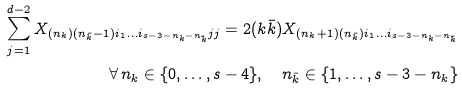<formula> <loc_0><loc_0><loc_500><loc_500>\sum _ { j = 1 } ^ { d - 2 } X _ { ( n _ { k } ) ( n _ { \bar { k } } - 1 ) i _ { 1 } \dots i _ { s - 3 - n _ { k } - n _ { \bar { k } } } j j } = 2 ( k \bar { k } ) X _ { ( n _ { k } + 1 ) ( n _ { \bar { k } } ) i _ { 1 } \dots i _ { s - 3 - n _ { k } - n _ { \bar { k } } } } \\ \forall \, n _ { k } \in \{ 0 , \dots , s - 4 \} , \quad n _ { \bar { k } } \in \{ 1 , \dots , s - 3 - n _ { k } \}</formula> 